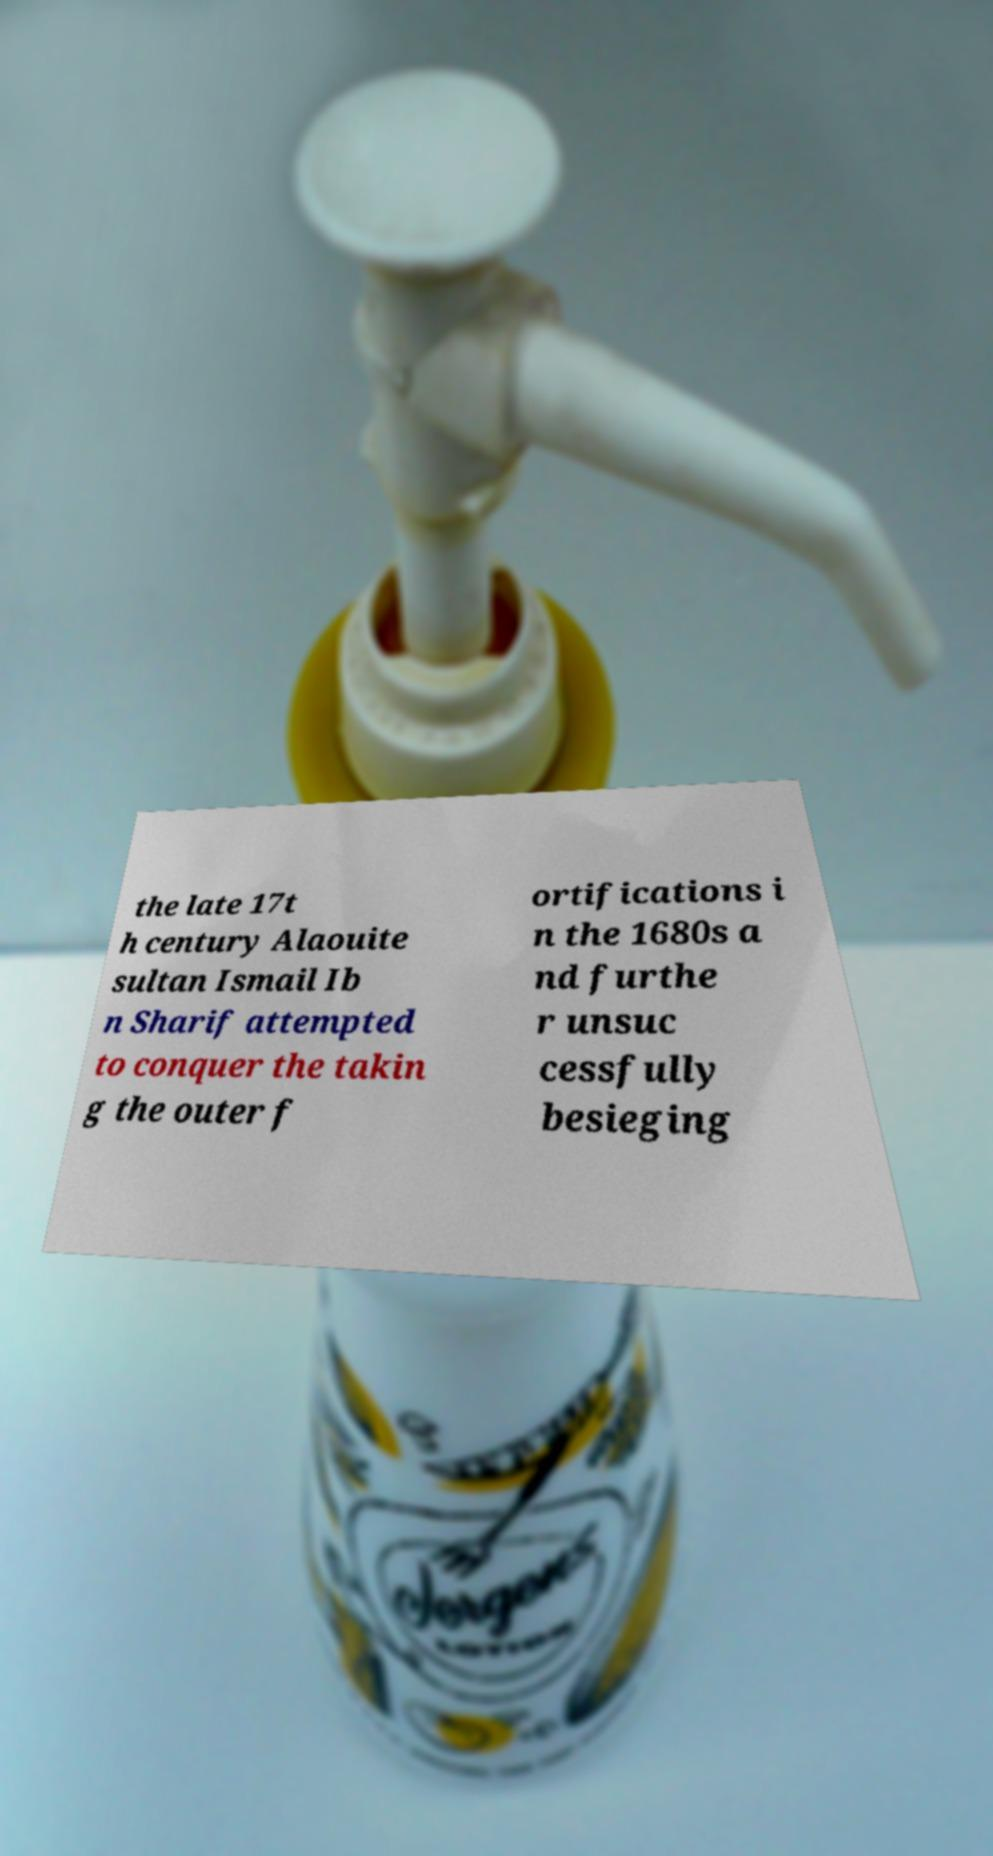There's text embedded in this image that I need extracted. Can you transcribe it verbatim? the late 17t h century Alaouite sultan Ismail Ib n Sharif attempted to conquer the takin g the outer f ortifications i n the 1680s a nd furthe r unsuc cessfully besieging 